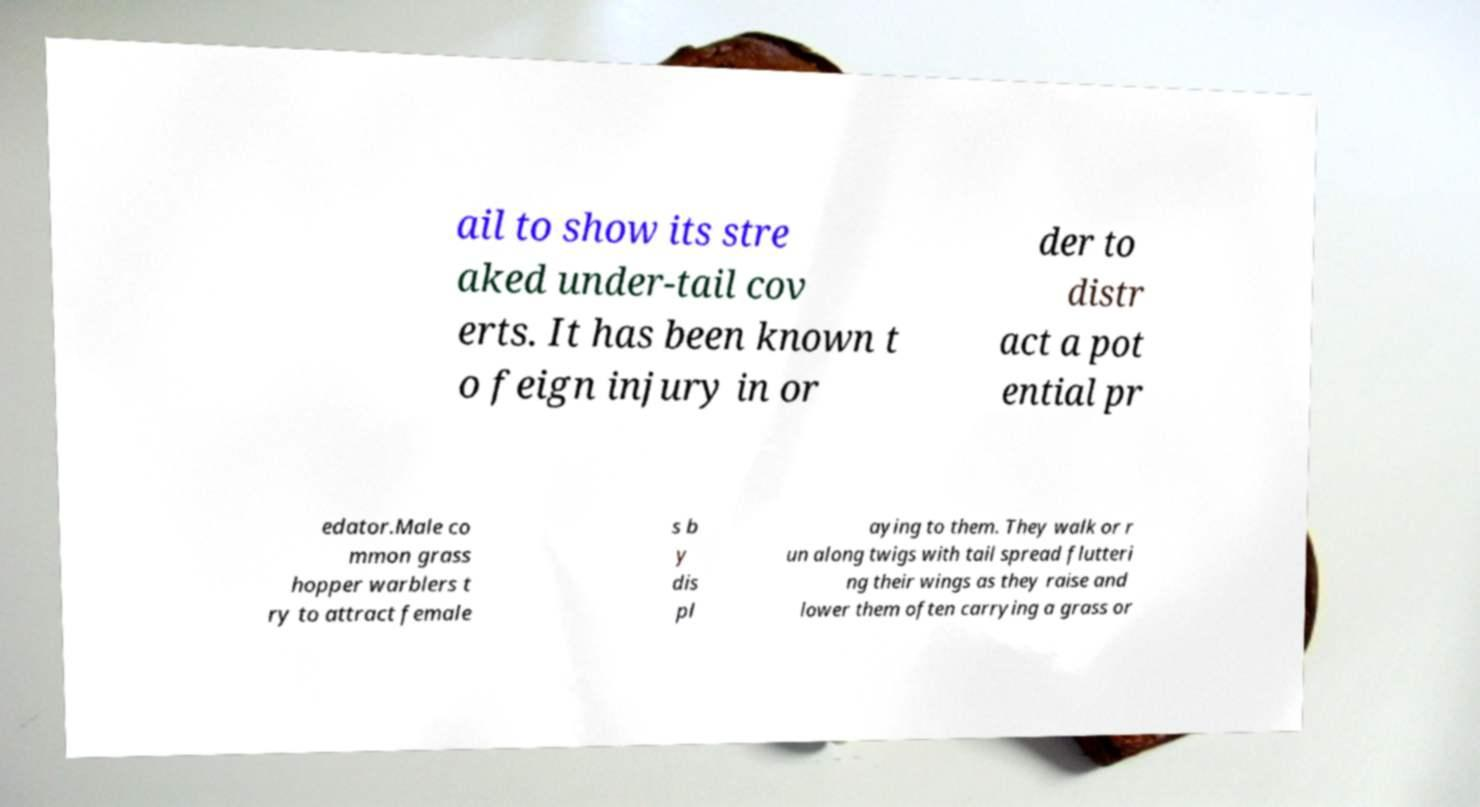Please identify and transcribe the text found in this image. ail to show its stre aked under-tail cov erts. It has been known t o feign injury in or der to distr act a pot ential pr edator.Male co mmon grass hopper warblers t ry to attract female s b y dis pl aying to them. They walk or r un along twigs with tail spread flutteri ng their wings as they raise and lower them often carrying a grass or 